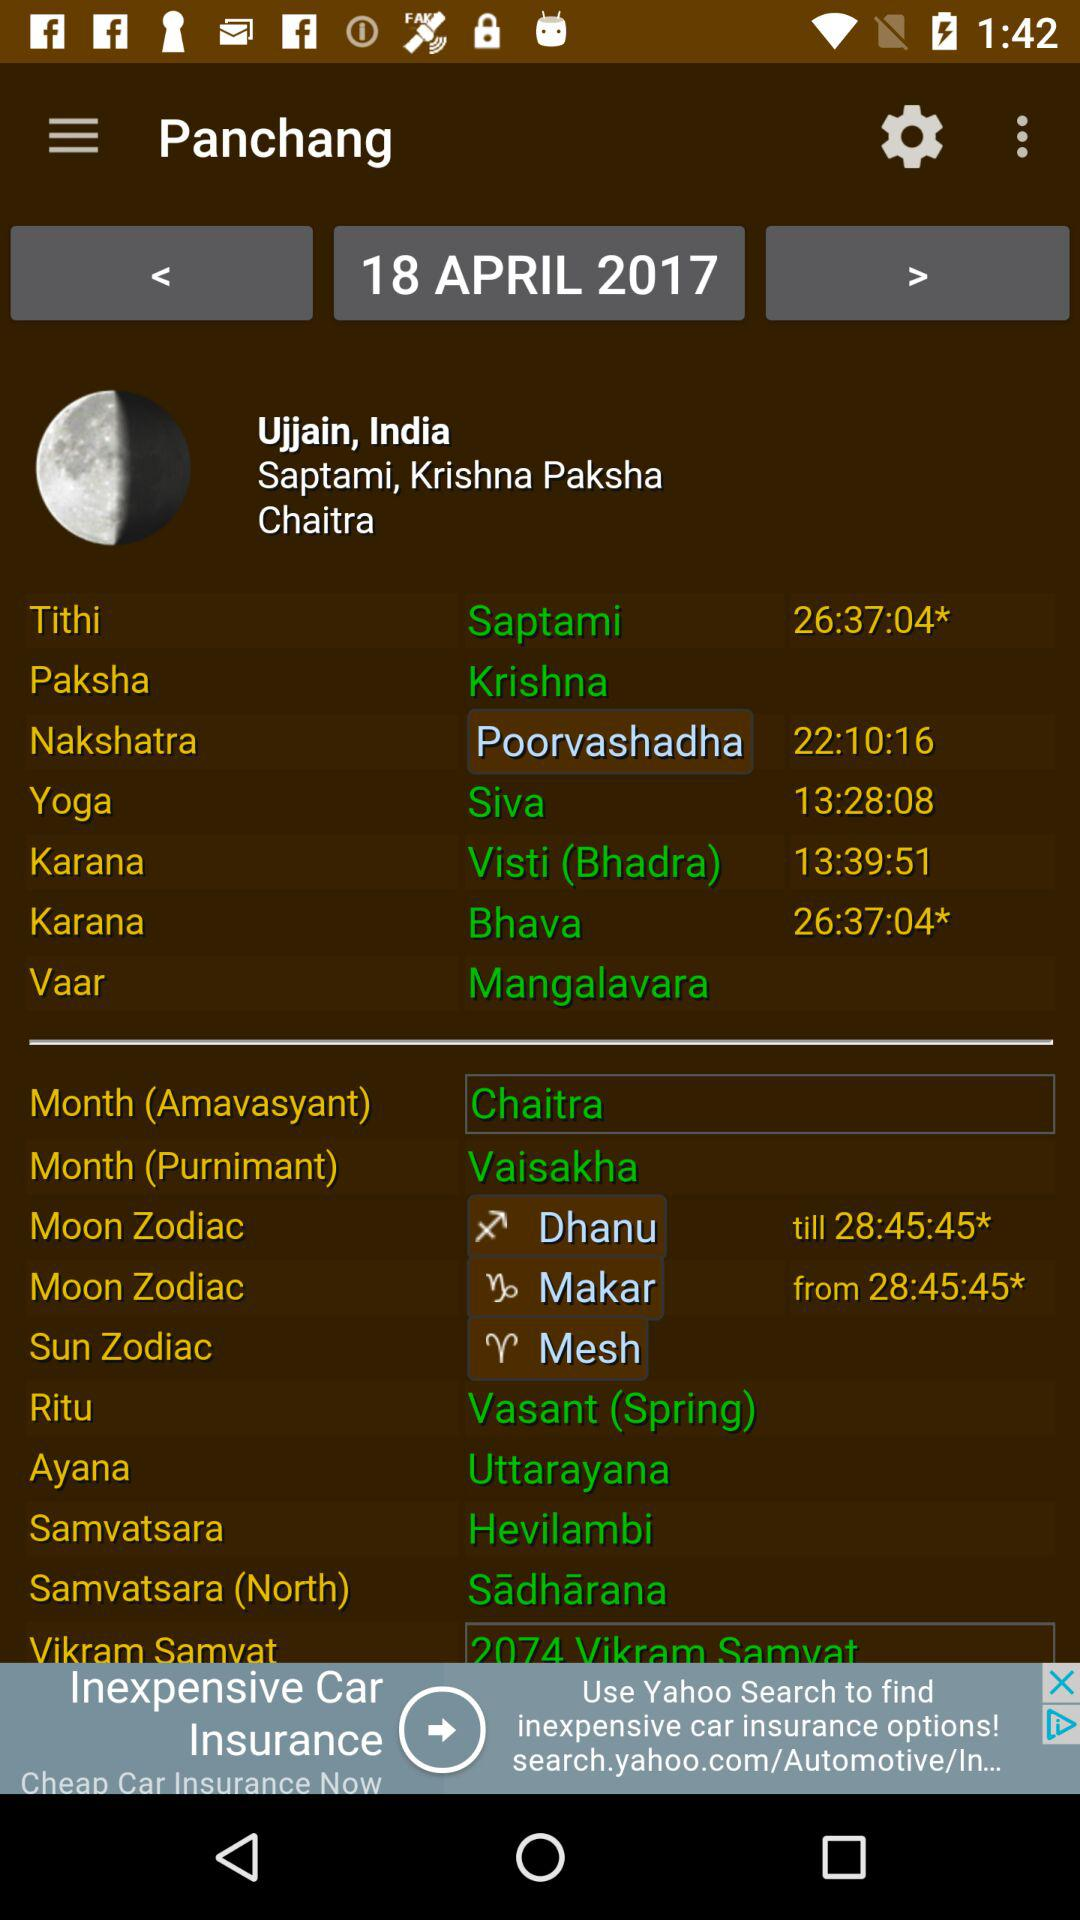Which date is displayed on the screen? The date April 18, 2017 is displayed on the screen. 